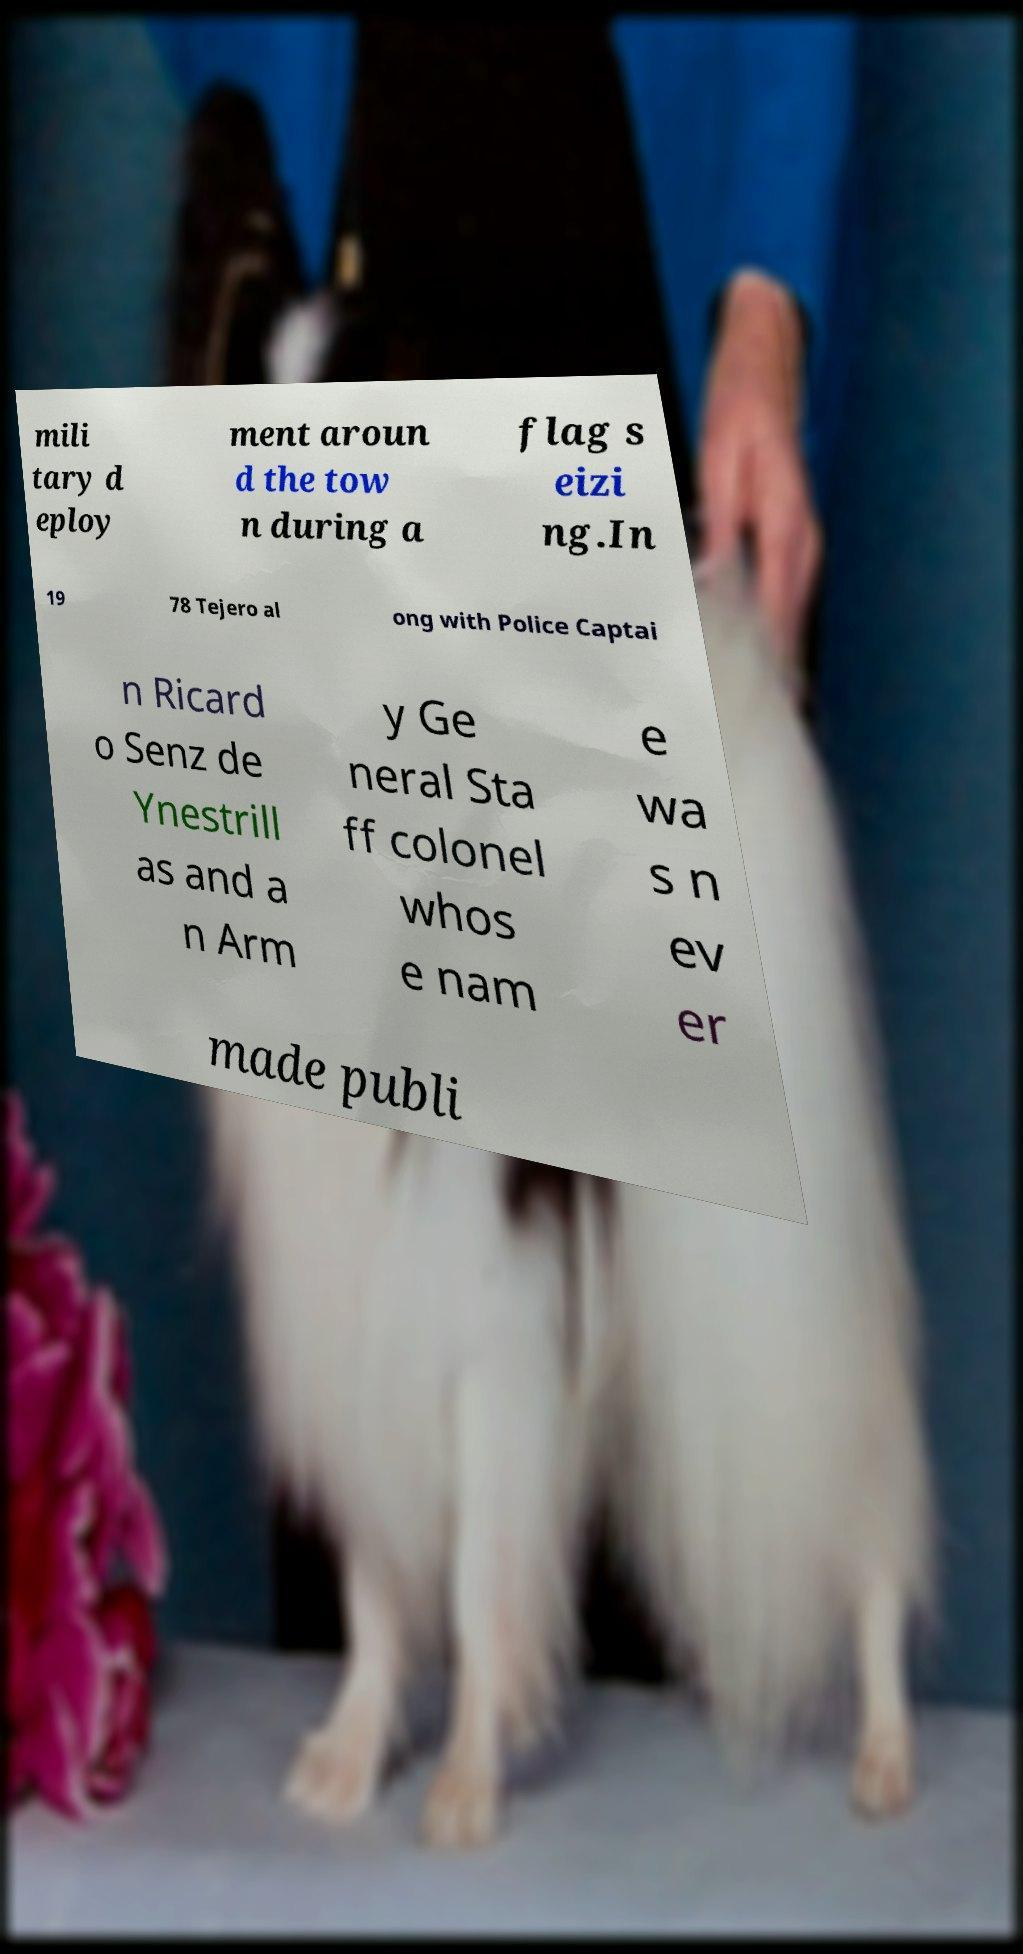There's text embedded in this image that I need extracted. Can you transcribe it verbatim? mili tary d eploy ment aroun d the tow n during a flag s eizi ng.In 19 78 Tejero al ong with Police Captai n Ricard o Senz de Ynestrill as and a n Arm y Ge neral Sta ff colonel whos e nam e wa s n ev er made publi 